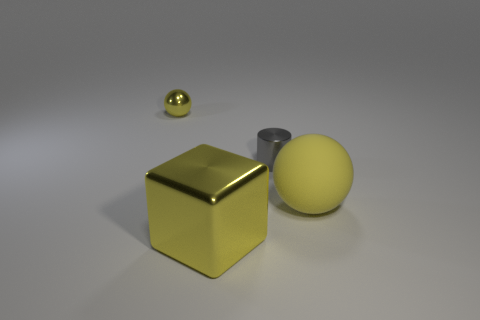Add 2 small rubber objects. How many objects exist? 6 Subtract all blocks. How many objects are left? 3 Subtract 1 yellow cubes. How many objects are left? 3 Subtract all brown shiny things. Subtract all gray objects. How many objects are left? 3 Add 2 big yellow objects. How many big yellow objects are left? 4 Add 2 big gray shiny cubes. How many big gray shiny cubes exist? 2 